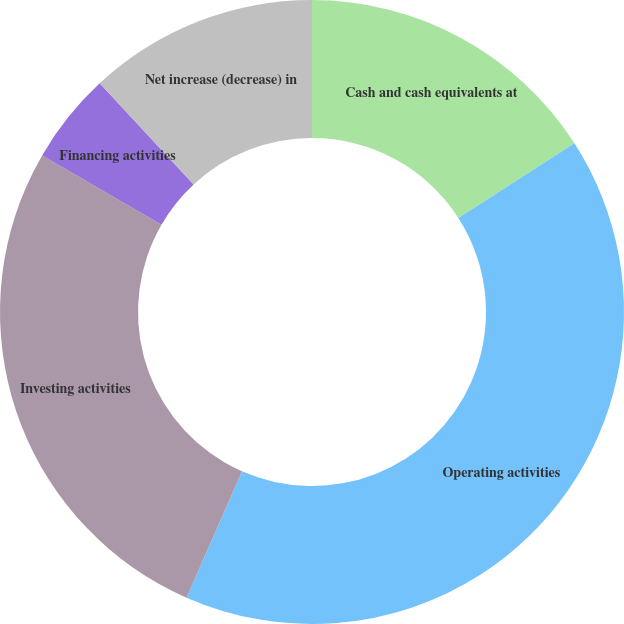Convert chart to OTSL. <chart><loc_0><loc_0><loc_500><loc_500><pie_chart><fcel>Cash and cash equivalents at<fcel>Operating activities<fcel>Investing activities<fcel>Financing activities<fcel>Net increase (decrease) in<nl><fcel>15.91%<fcel>40.68%<fcel>26.78%<fcel>4.72%<fcel>11.91%<nl></chart> 